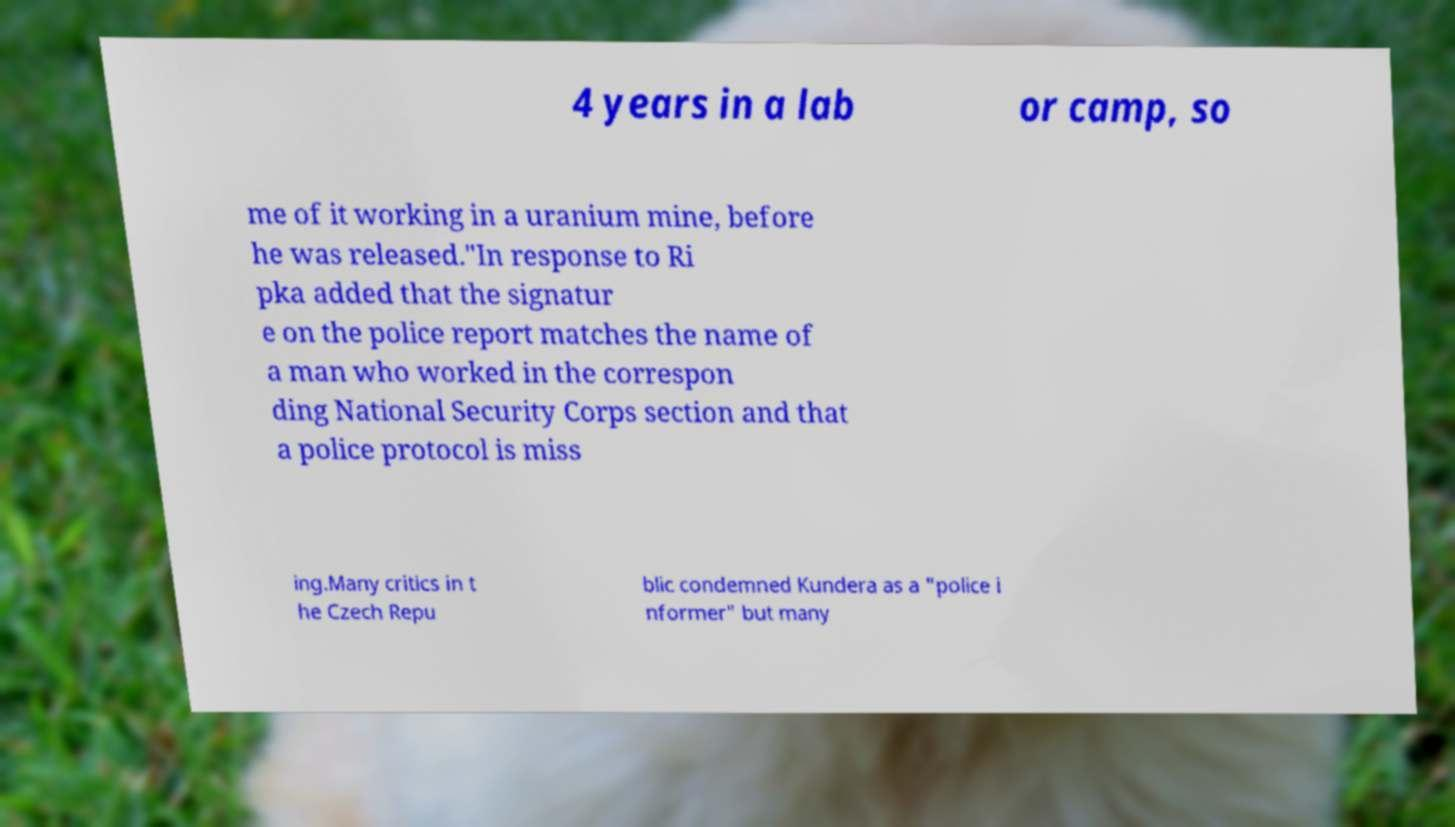Please read and relay the text visible in this image. What does it say? 4 years in a lab or camp, so me of it working in a uranium mine, before he was released."In response to Ri pka added that the signatur e on the police report matches the name of a man who worked in the correspon ding National Security Corps section and that a police protocol is miss ing.Many critics in t he Czech Repu blic condemned Kundera as a "police i nformer" but many 